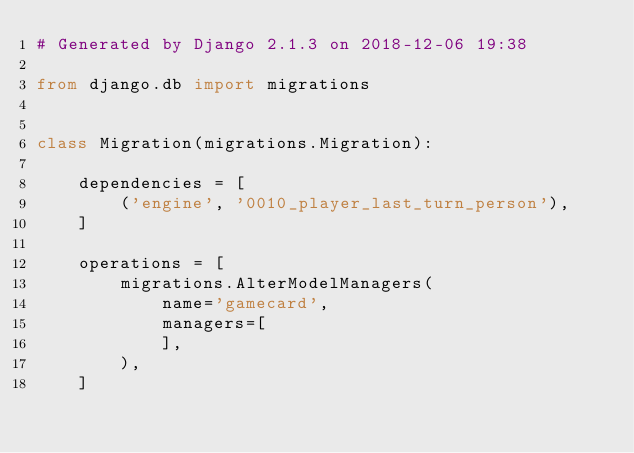<code> <loc_0><loc_0><loc_500><loc_500><_Python_># Generated by Django 2.1.3 on 2018-12-06 19:38

from django.db import migrations


class Migration(migrations.Migration):

    dependencies = [
        ('engine', '0010_player_last_turn_person'),
    ]

    operations = [
        migrations.AlterModelManagers(
            name='gamecard',
            managers=[
            ],
        ),
    ]
</code> 